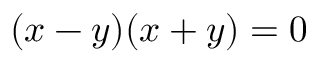Convert formula to latex. <formula><loc_0><loc_0><loc_500><loc_500>( x - y ) ( x + y ) = 0</formula> 